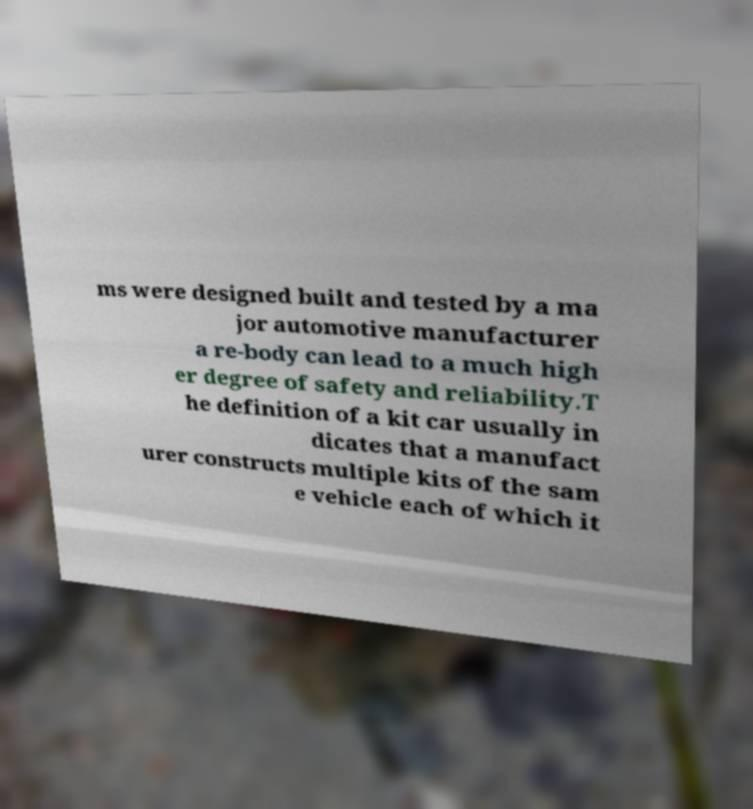There's text embedded in this image that I need extracted. Can you transcribe it verbatim? ms were designed built and tested by a ma jor automotive manufacturer a re-body can lead to a much high er degree of safety and reliability.T he definition of a kit car usually in dicates that a manufact urer constructs multiple kits of the sam e vehicle each of which it 